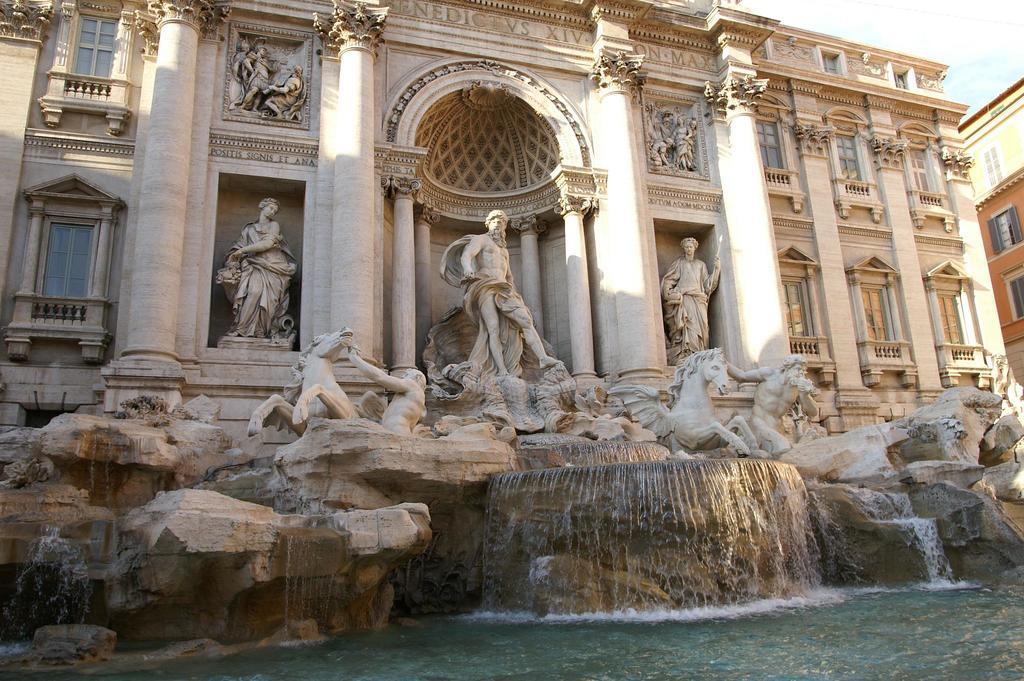How would you summarize this image in a sentence or two? In this picture, it is called as a "Trevi Fountain". On the right side of the fountain there is a building. Behind the building there is the sky. 